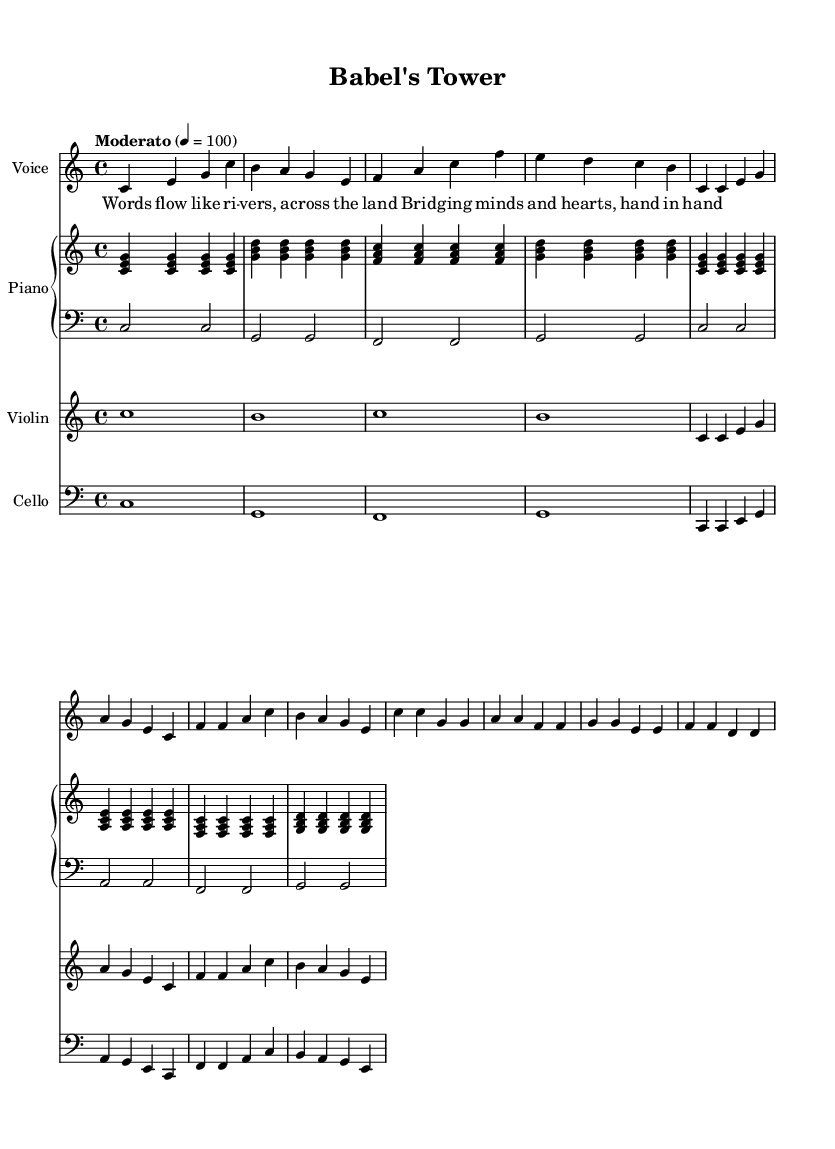What is the key signature of this music? The key signature is C major, which has no sharps or flats indicated. This can be determined by observing the beginning of the staff where the key signature is shown.
Answer: C major What is the time signature of this piece? The time signature is 4/4, which indicates that there are four beats in each measure and a quarter note receives one beat. This is shown at the start of the score.
Answer: 4/4 What is the tempo marking for this song? The tempo marking is "Moderato," indicating a moderate speed. This is often found at the beginning of the music after the key signature.
Answer: Moderato Which instrument plays the melody in the introduction? The voice instrument plays the melody in the introduction as it is the first staff listed and contains the melodic line.
Answer: Voice How many different instruments are used in this piece? There are four different instruments used: Voice, Piano, Violin, and Cello. This can be counted by looking at the various staves in the score.
Answer: Four What is the lyric for the first line of the verse? The first line of the verse is "Words flow like ri -- vers, a -- cross the land." This can be found in the lyrics section right under the corresponding vocal line.
Answer: Words flow like ri -- vers, a -- cross the land Which section of the song is referred to as the chorus? The section labeled "Chorus" is where the lyrics begin with "Ba -- bel's To -- wer, ri -- sing high." The section is clearly marked in the sheet music.
Answer: Chorus 